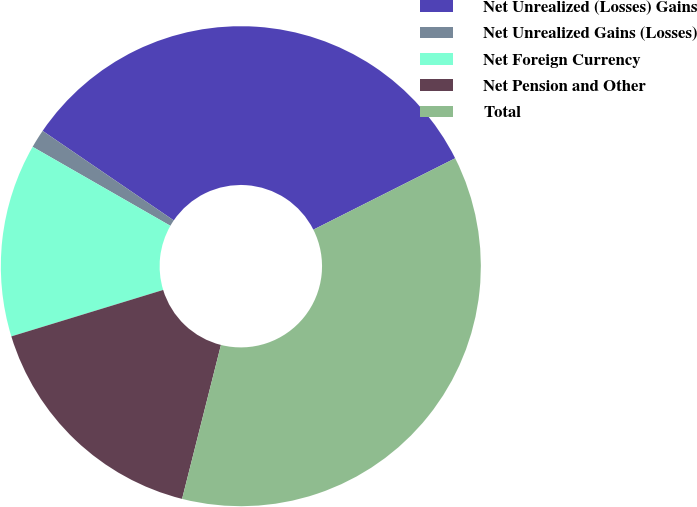<chart> <loc_0><loc_0><loc_500><loc_500><pie_chart><fcel>Net Unrealized (Losses) Gains<fcel>Net Unrealized Gains (Losses)<fcel>Net Foreign Currency<fcel>Net Pension and Other<fcel>Total<nl><fcel>33.04%<fcel>1.25%<fcel>13.01%<fcel>16.34%<fcel>36.36%<nl></chart> 